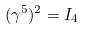Convert formula to latex. <formula><loc_0><loc_0><loc_500><loc_500>( \gamma ^ { 5 } ) ^ { 2 } = I _ { 4 }</formula> 